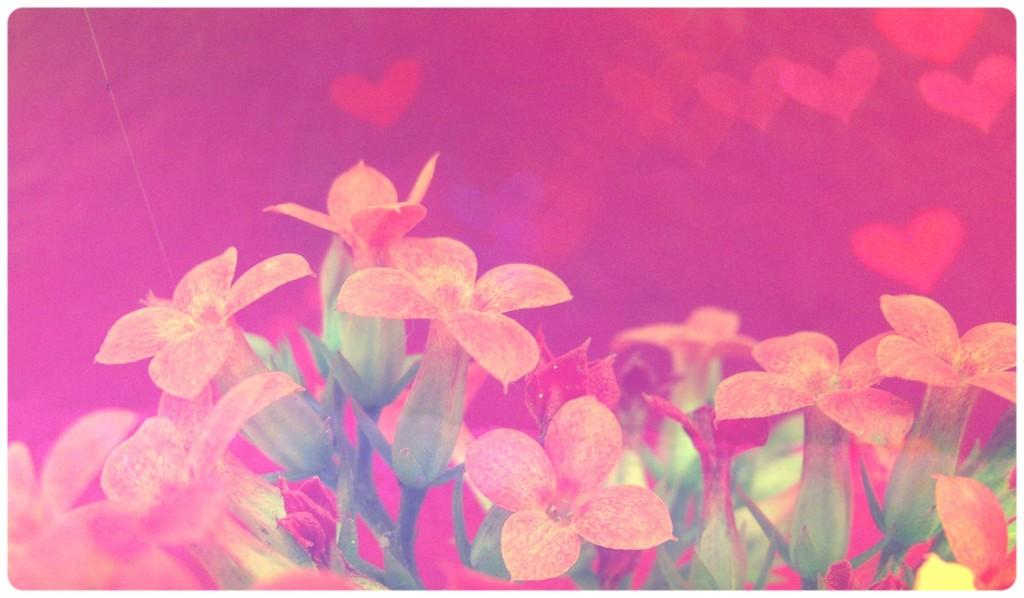What can be observed about the image's appearance? The image is edited. What type of flora is present in the image? There are flowers in the image. What color is the background of the image? The background of the image is pink. What position does the rat hold in the image? There is no rat present in the image. What territory is depicted in the image? The image does not depict any specific territory; it features flowers and a pink background. 